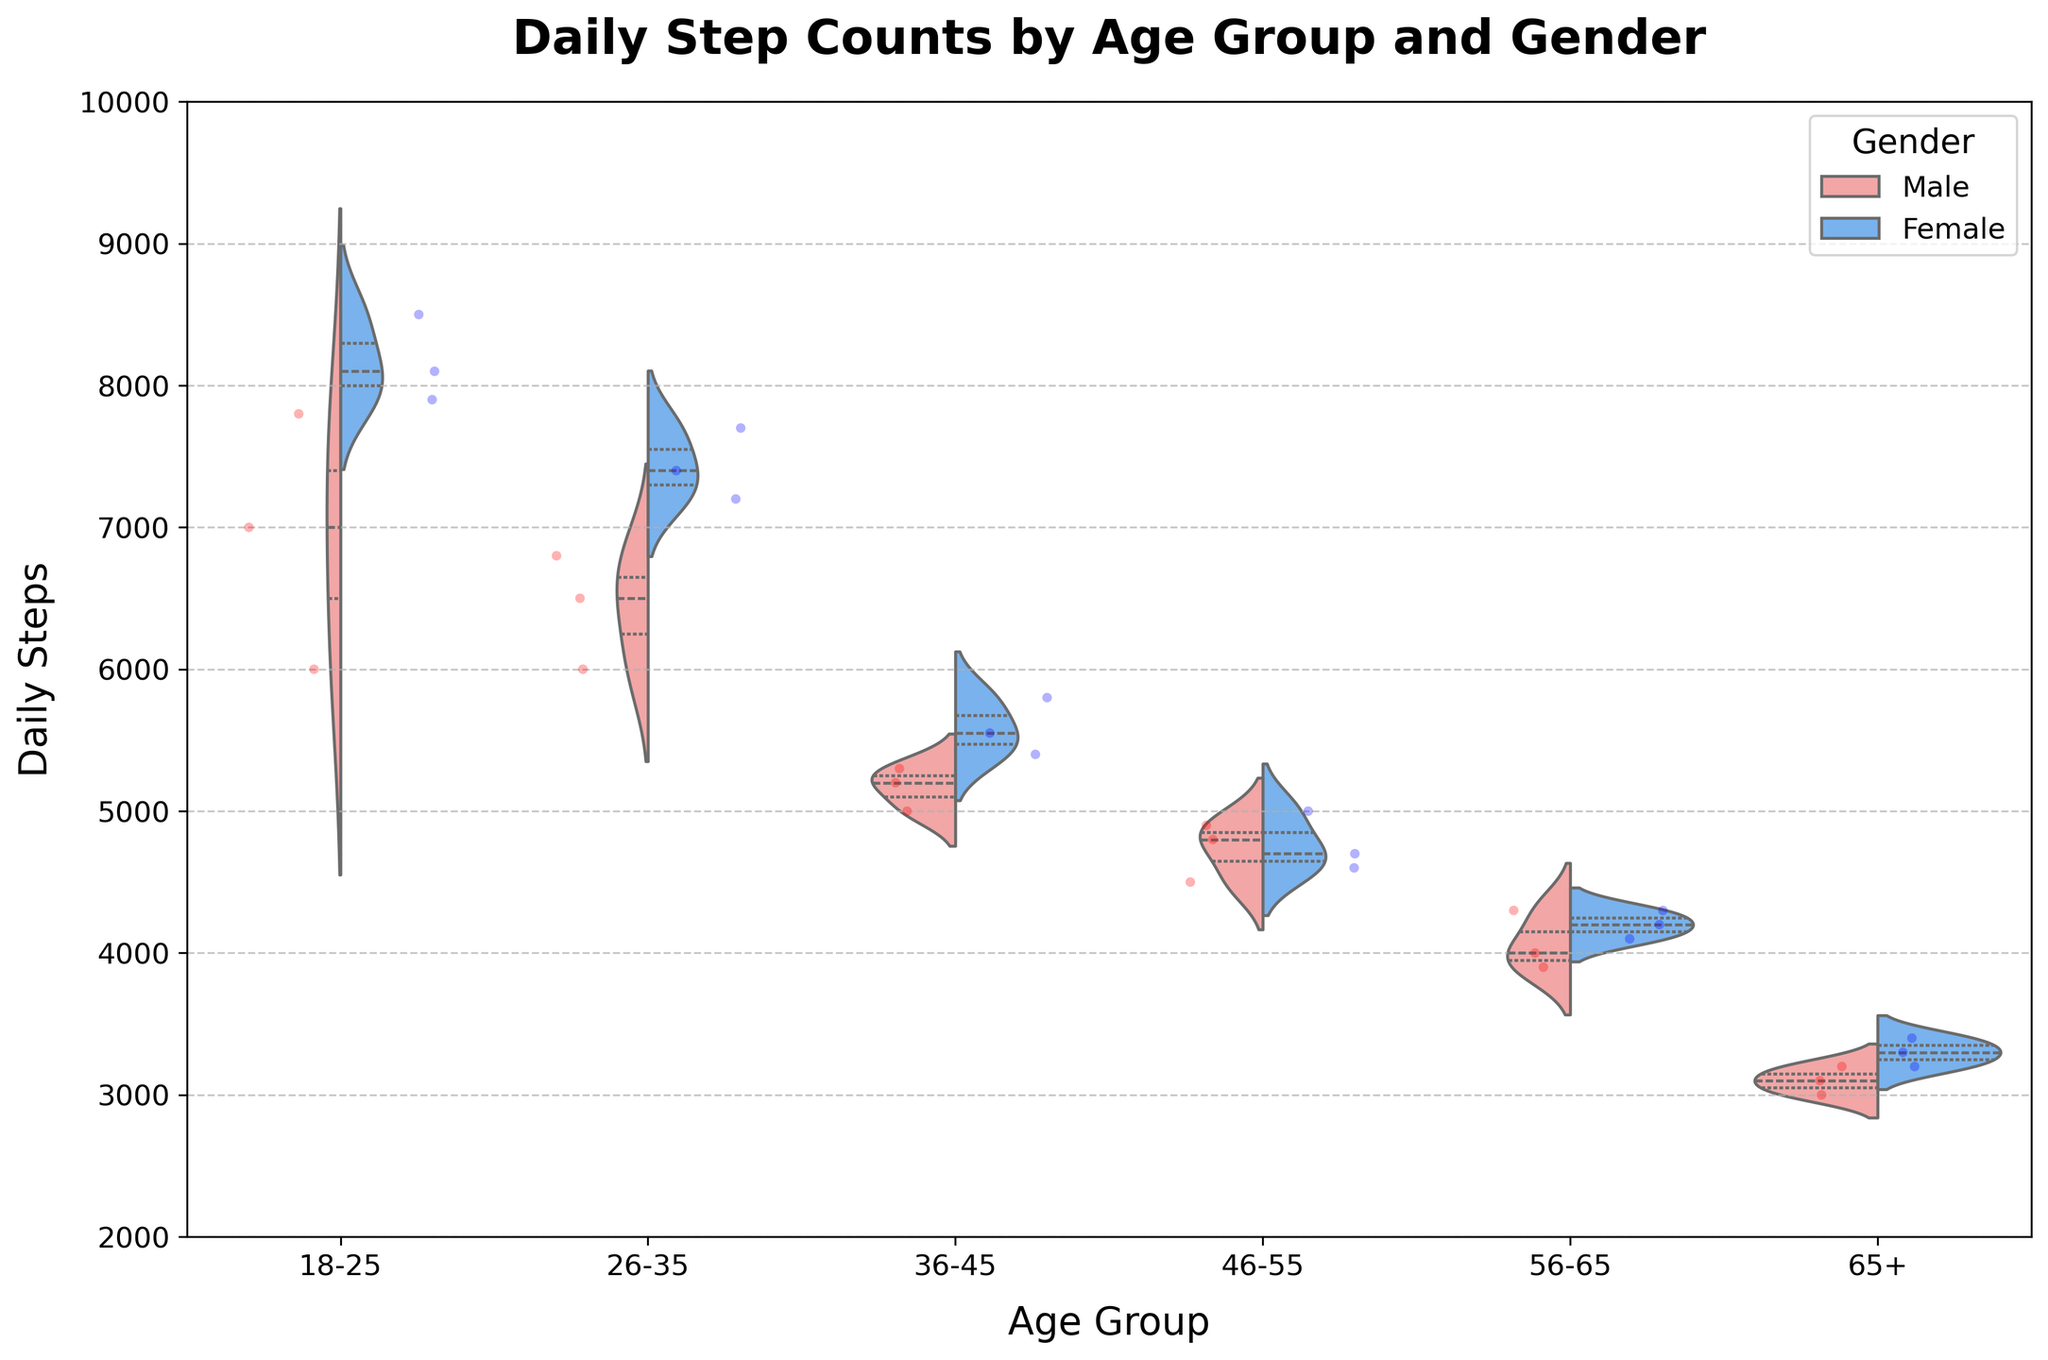What is the title of the chart? The title is generally located at the top of the chart and serves to provide an overview of what the chart represents.
Answer: Daily Step Counts by Age Group and Gender Which age group has the highest median daily steps for males? The median is shown by the thick line inside the violin plot segment. For males, look at all the age groups and identify which violin plot segment's thick line is positioned higher.
Answer: 18-25 Which gender generally has higher daily steps in the 26-35 age group? Compare the positions of the median lines within the 26-35 age group's violin plot. The gender with the higher median line has higher daily steps in this age group.
Answer: Female How do the daily steps of males and females compare in the 46-55 age group? Observe the median lines of the male and female distributions within the 46-55 age group's violin plot. Compare their positions and note their differences.
Answer: Females have slightly higher daily steps What is the range of daily steps shown on the y-axis? The y-axis range is displayed on the left side of the chart, showing the overall spread of daily steps.
Answer: 2000 to 10000 In which age group is the difference between male and female median step counts the largest? Check the difference between the male and female median lines for each age group. The age group with the largest gap between the medians shows the largest difference.
Answer: 18-25 What can you infer about the step distribution for the 65+ age group? The shape and width of the violin plots reveal information about the distribution. For the 65+ group, the plots are narrower, indicating less variation in steps.
Answer: Narrow distributions indicate less variation Why are jittered points used in this chart? Jittered points are added to help visually represent individual data points and avoid overlapping, providing a clearer picture of the distribution at specific values.
Answer: To represent individual data points clearly What does the quartile information inside the violin plots represent? The quartile information includes the median, first quartile (25th percentile), and third quartile (75th percentile), providing insights into the data's spread.
Answer: Median, first, and third quartiles Which age group shows the narrowest spread in daily steps for both genders? Look at the width of the violin plots for each age group. The group with the narrowest plots indicates the least spread in daily steps.
Answer: 65+ 